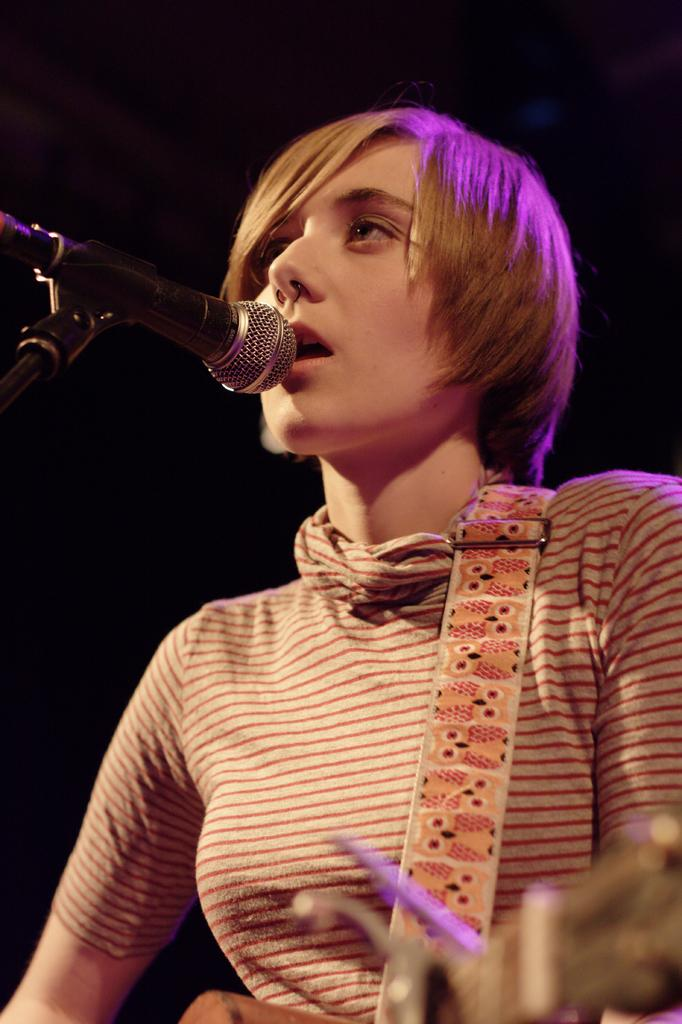Who is the main subject in the image? There is a woman in the image. What is the woman doing in the image? The woman is singing and playing a guitar. Can you describe the background of the image? The background of the image is too dark. How many lizards are present in the image? There are no lizards present in the image. What story is the woman telling in the image? The image does not depict the woman telling a story; she is singing and playing a guitar. 